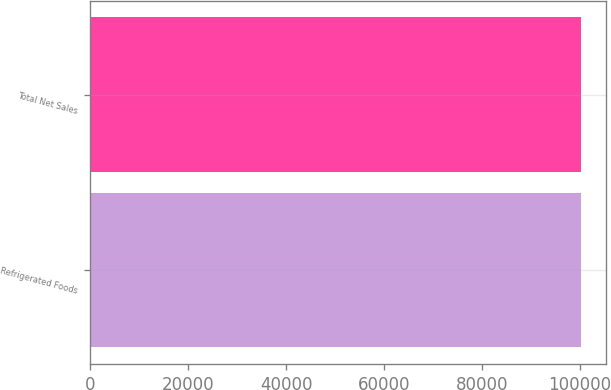Convert chart to OTSL. <chart><loc_0><loc_0><loc_500><loc_500><bar_chart><fcel>Refrigerated Foods<fcel>Total Net Sales<nl><fcel>100231<fcel>100231<nl></chart> 